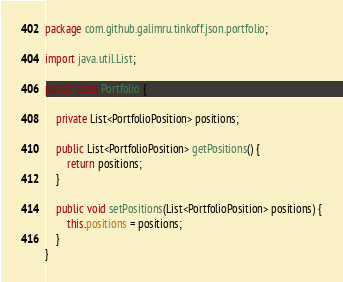<code> <loc_0><loc_0><loc_500><loc_500><_Java_>package com.github.galimru.tinkoff.json.portfolio;

import java.util.List;

public class Portfolio {

    private List<PortfolioPosition> positions;

    public List<PortfolioPosition> getPositions() {
        return positions;
    }

    public void setPositions(List<PortfolioPosition> positions) {
        this.positions = positions;
    }
}
</code> 